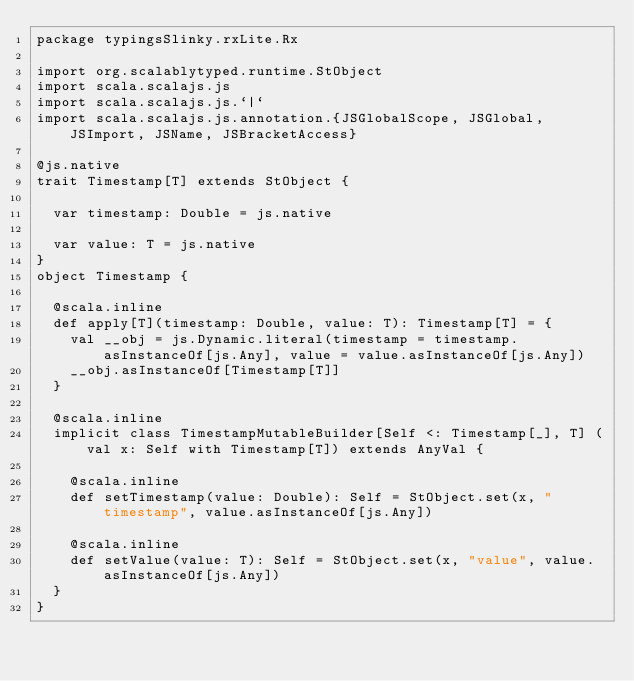Convert code to text. <code><loc_0><loc_0><loc_500><loc_500><_Scala_>package typingsSlinky.rxLite.Rx

import org.scalablytyped.runtime.StObject
import scala.scalajs.js
import scala.scalajs.js.`|`
import scala.scalajs.js.annotation.{JSGlobalScope, JSGlobal, JSImport, JSName, JSBracketAccess}

@js.native
trait Timestamp[T] extends StObject {
  
  var timestamp: Double = js.native
  
  var value: T = js.native
}
object Timestamp {
  
  @scala.inline
  def apply[T](timestamp: Double, value: T): Timestamp[T] = {
    val __obj = js.Dynamic.literal(timestamp = timestamp.asInstanceOf[js.Any], value = value.asInstanceOf[js.Any])
    __obj.asInstanceOf[Timestamp[T]]
  }
  
  @scala.inline
  implicit class TimestampMutableBuilder[Self <: Timestamp[_], T] (val x: Self with Timestamp[T]) extends AnyVal {
    
    @scala.inline
    def setTimestamp(value: Double): Self = StObject.set(x, "timestamp", value.asInstanceOf[js.Any])
    
    @scala.inline
    def setValue(value: T): Self = StObject.set(x, "value", value.asInstanceOf[js.Any])
  }
}
</code> 